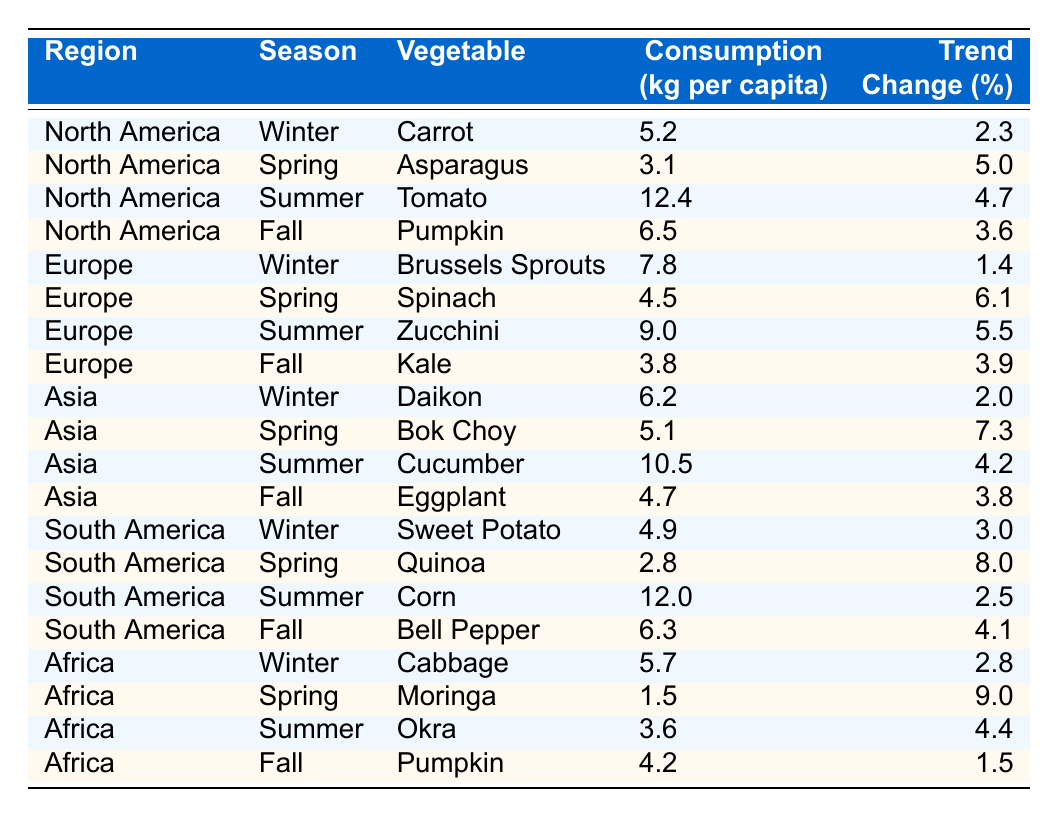What is the highest vegetable consumption in North America during summer? In North America, the vegetable consumed the most in summer is Tomato with a consumption of 12.4 kg per capita.
Answer: 12.4 kg Which South American vegetable has the lowest winter consumption? In South America during winter, the vegetable with the lowest consumption is Sweet Potato at 4.9 kg per capita.
Answer: 4.9 kg Is the consumption of Quinoa in South America increasing? The trend change for Quinoa in South America during spring is 8.0%, indicating an increase in consumption.
Answer: Yes What is the average vegetable consumption in Europe across all seasons? To calculate the average, we sum the consumption values for Europe across all seasons: (7.8 + 4.5 + 9.0 + 3.8) = 25.1 kg. There are 4 seasons, so the average is 25.1 / 4 = 6.275 kg.
Answer: 6.3 kg Which region consumes the most Cucumber and in which season? In Asia during summer, the highest consumption of Cucumber is recorded at 10.5 kg per capita.
Answer: 10.5 kg (Asia, Summer) Has the trend for Moringa consumption in Africa changed positively or negatively? The trend change for Moringa in Africa during spring is 9.0%, indicating a positive change in consumption.
Answer: Positive Which vegetable in Winter has the highest consumption in Europe? In Europe during winter, Brussels Sprouts has the highest consumption at 7.8 kg per capita.
Answer: 7.8 kg What is the difference in vegetable consumption between summer and fall in South America? To find the difference, we compare the highest summer consumption of Corn (12.0 kg) and the fall consumption of Bell Pepper (6.3 kg). The difference is 12.0 - 6.3 = 5.7 kg.
Answer: 5.7 kg Which vegetable showed the largest trend increase in Asia during spring? In Asia during spring, Bok Choy exhibited the largest trend increase with a change of 7.3%.
Answer: 7.3% What is the trend change percentage for Pumpkin in Africa during fall? The trend change percentage for Pumpkin in Africa during fall is 1.5%.
Answer: 1.5% 